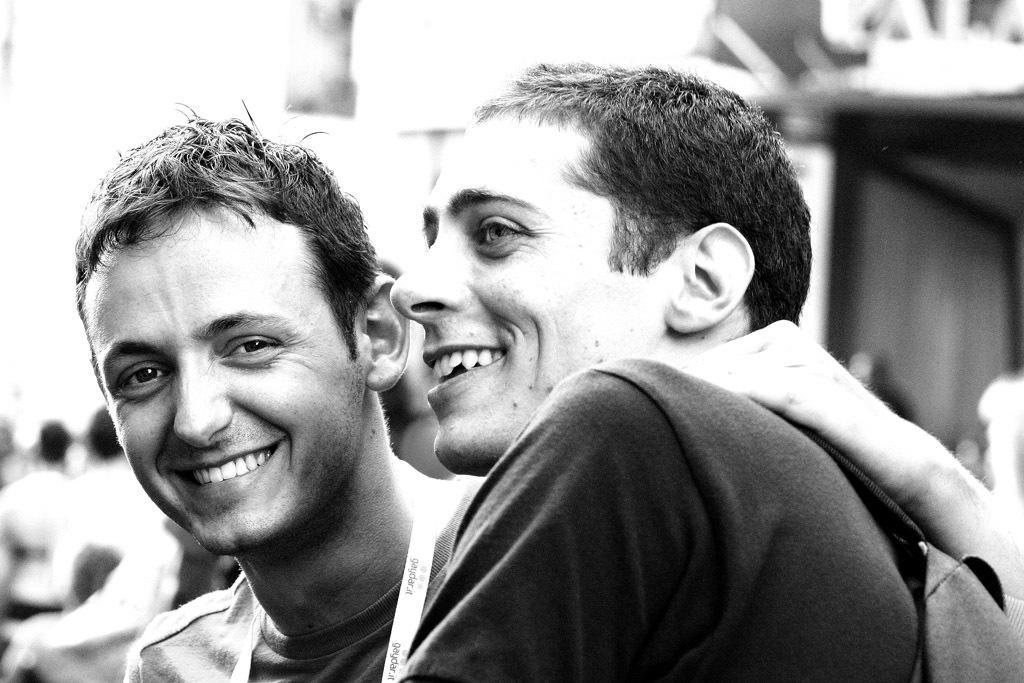In one or two sentences, can you explain what this image depicts? It is a black and white image of two persons smiling and the background is blurry. 